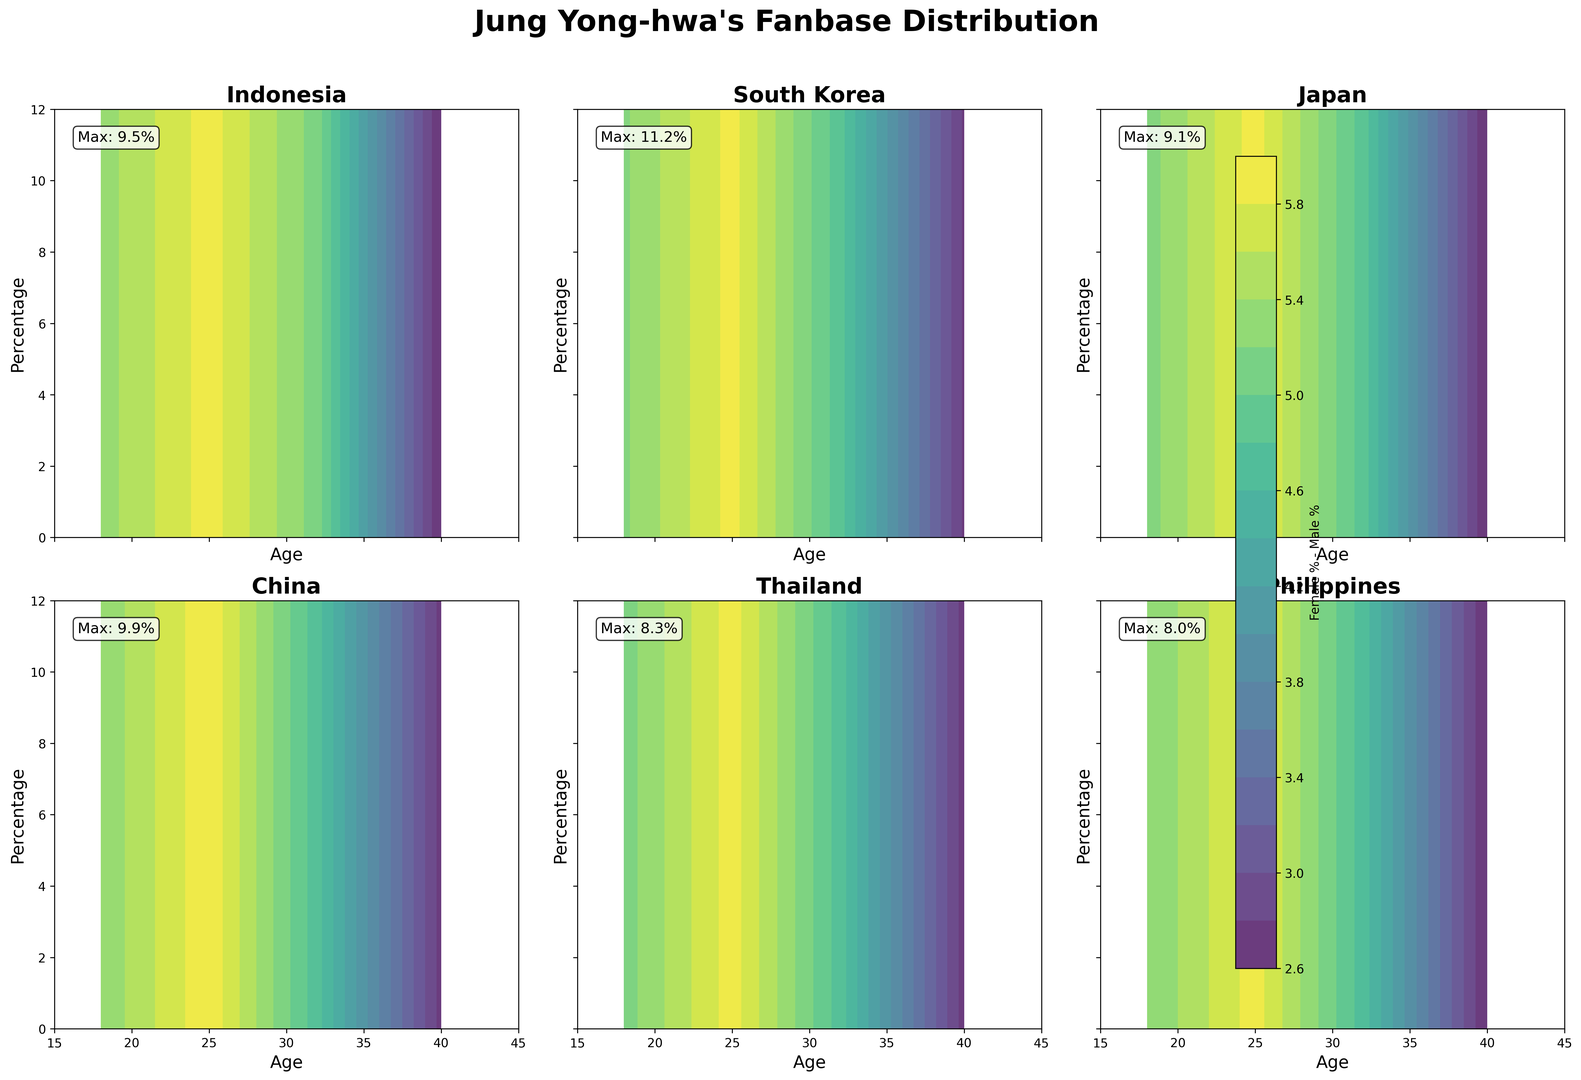Which country has the highest percentage difference between female and male fans aged 25? By looking at the contour plot, identify the country subplot and compare the percentage values for female and male fans aged 25. South Korea shows the highest difference.
Answer: South Korea In Indonesia, which gender has a higher fan percentage, and by how much, for fans aged 32? Identify Indonesia's subplot, check the percentages for both genders at age 32, and calculate the difference. Females have 7.8%, and males have 1.9%. The difference is 7.8% - 1.9% = 5.9%
Answer: Female, 5.9% Among the provided countries, which country shows the lowest percentage for male fans aged 40? Look at all country subplots and compare the male fan percentages at age 40. The Philippines shows the lowest percentage with 0.7%.
Answer: Philippines What is the average female fan percentage for the age group 18-25 across all countries? Sum the female fan percentages for age 18 and 25 for all countries, then divide by the number of data points. (8.2+9.5+9.7+11.2+7.8+9.1+8.5+9.9+7.1+8.3+6.9+8.0)/12 = 8.6333
Answer: 8.6% Which country has the most balanced fan distribution between males and females aged 18? Look at the contour plots and compare the differences between male and female percentages at age 18 for each country. The Philippines has the smallest difference, with 6.9% (female) and 1.7% (male).
Answer: Philippines What is the percentage difference between female fans aged 25 and 32 in China? Identify China's subplot, check the percentages for females aged 25 and 32, and calculate the difference. 25: 9.9%, 32: 7.6%. Difference: 9.9% - 7.6% = 2.3%
Answer: 2.3% Which group has the highest female fan percentage among 18-year-olds across all countries? Find the subplot for each country and compare the female fan percentages for 18-year-olds. South Korea shows the highest percentage with 9.7%.
Answer: South Korea Which country shows a sharper decrease in female fan percentage from age 25 to 40, Japan or Thailand? Look at the contour plots for Japan and Thailand, check the female percentages at ages 25 and 40, and compare the differences. Japan: 9.1% to 3.9%, difference is 5.2%. Thailand: 8.3% to 3.5%, difference is 4.8%.
Answer: Japan 